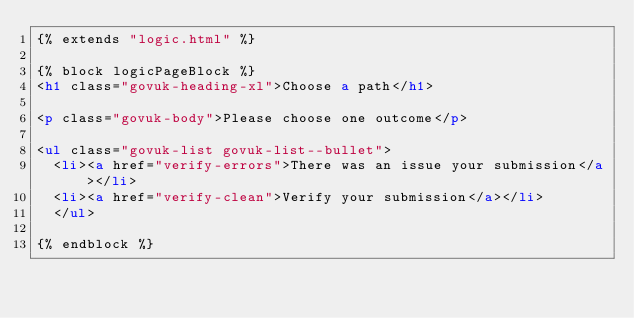<code> <loc_0><loc_0><loc_500><loc_500><_HTML_>{% extends "logic.html" %}

{% block logicPageBlock %}
<h1 class="govuk-heading-xl">Choose a path</h1>

<p class="govuk-body">Please choose one outcome</p>

<ul class="govuk-list govuk-list--bullet">
  <li><a href="verify-errors">There was an issue your submission</a></li>
  <li><a href="verify-clean">Verify your submission</a></li>
  </ul>

{% endblock %}
</code> 